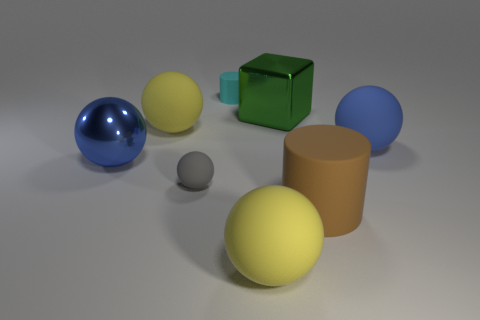What is the material of the big green object?
Give a very brief answer. Metal. There is another tiny thing that is the same material as the cyan object; what color is it?
Keep it short and to the point. Gray. Do the cyan thing and the large blue object behind the blue shiny sphere have the same material?
Make the answer very short. Yes. What number of large yellow balls have the same material as the gray ball?
Provide a short and direct response. 2. What is the shape of the big yellow matte thing in front of the big blue rubber thing?
Ensure brevity in your answer.  Sphere. Is the big yellow object that is left of the gray thing made of the same material as the large object that is on the right side of the big brown matte object?
Provide a succinct answer. Yes. Are there any gray matte objects of the same shape as the big green metal object?
Offer a terse response. No. What number of objects are either large yellow rubber things to the left of the gray rubber ball or yellow balls?
Ensure brevity in your answer.  2. Is the number of cyan cylinders on the left side of the tiny gray rubber sphere greater than the number of blue spheres to the right of the block?
Offer a very short reply. No. How many metallic things are either large yellow spheres or large spheres?
Your answer should be compact. 1. 